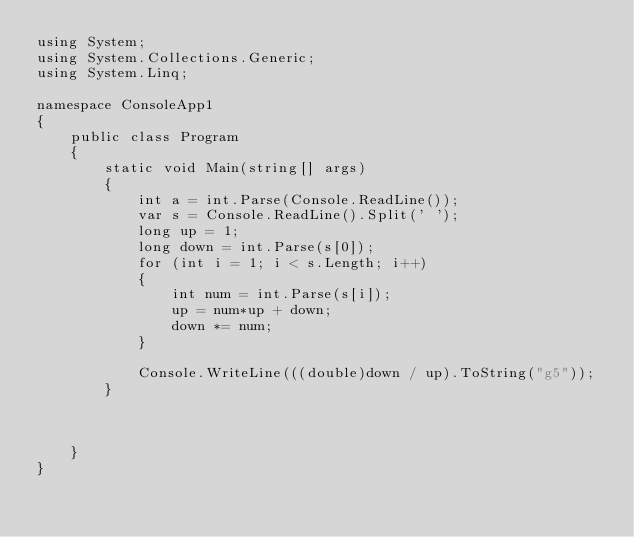Convert code to text. <code><loc_0><loc_0><loc_500><loc_500><_C#_>using System;
using System.Collections.Generic;
using System.Linq;

namespace ConsoleApp1
{
    public class Program
    {
        static void Main(string[] args)
        {
            int a = int.Parse(Console.ReadLine());
            var s = Console.ReadLine().Split(' ');
            long up = 1;
            long down = int.Parse(s[0]);
            for (int i = 1; i < s.Length; i++)
            {
                int num = int.Parse(s[i]);
                up = num*up + down;
                down *= num;
            }

            Console.WriteLine(((double)down / up).ToString("g5"));
        }



    }
}
</code> 